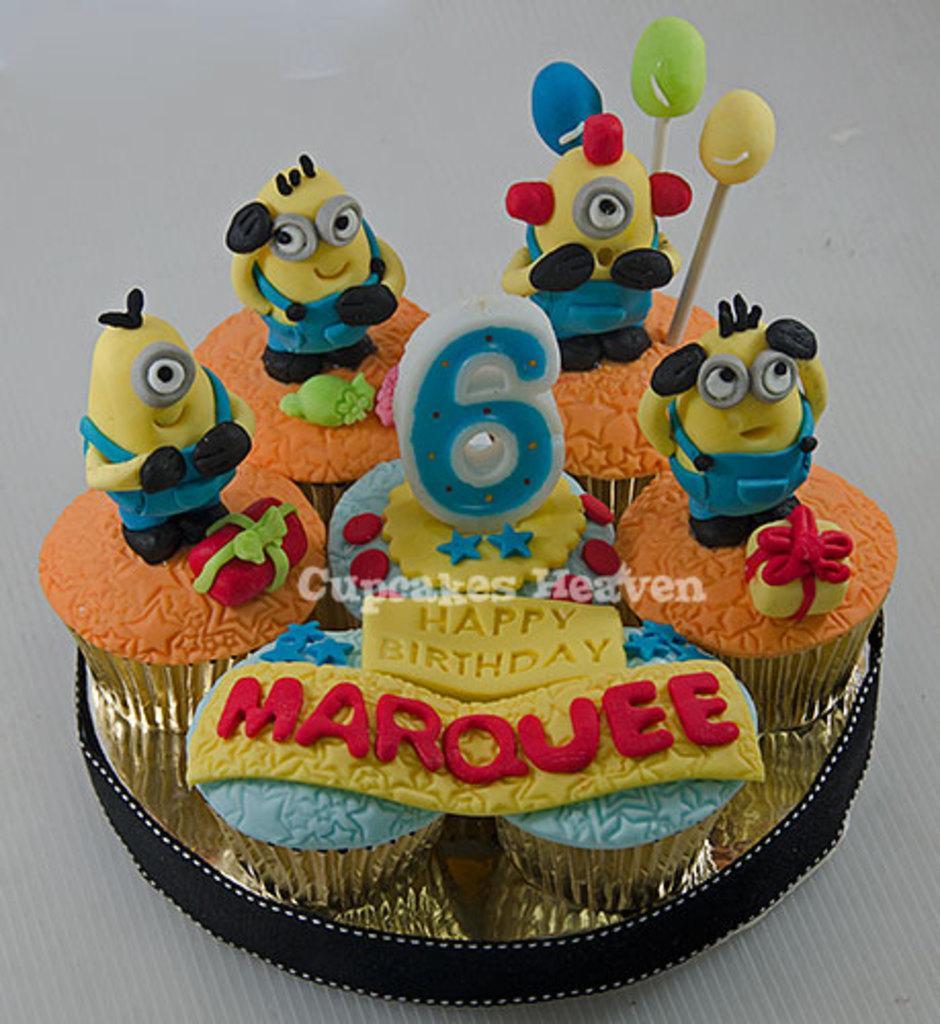Describe this image in one or two sentences. In the picture I can see cupcakes on which I can see cartoon characters and something written on them. The background of the image is white in color. I can also see a watermark on the image. 